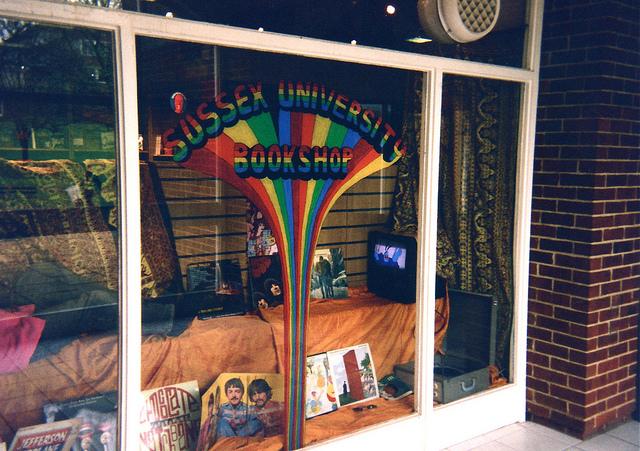Are there Beatles?
Concise answer only. Yes. Is there an image of a rainbow in the photo?
Keep it brief. Yes. What type of shop is this?
Write a very short answer. Bookshop. 